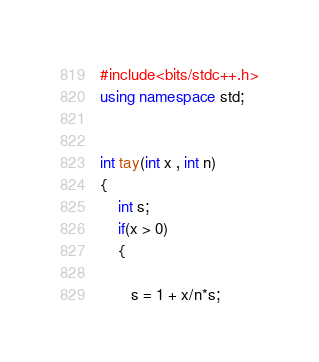Convert code to text. <code><loc_0><loc_0><loc_500><loc_500><_C++_>#include<bits/stdc++.h>
using namespace std;


int tay(int x , int n)
{
    int s;
    if(x > 0)
    {
       
       s = 1 + x/n*s;</code> 